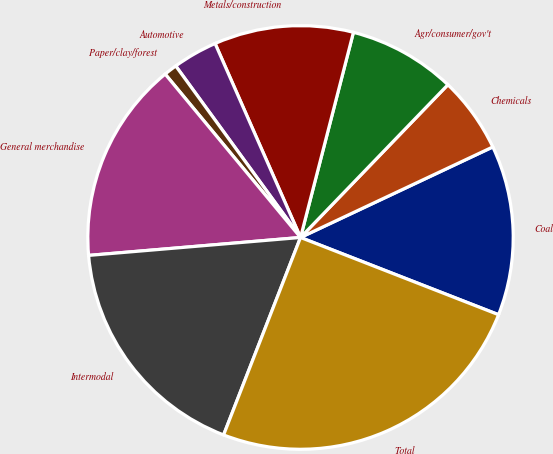<chart> <loc_0><loc_0><loc_500><loc_500><pie_chart><fcel>Coal<fcel>Chemicals<fcel>Agr/consumer/gov't<fcel>Metals/construction<fcel>Automotive<fcel>Paper/clay/forest<fcel>General merchandise<fcel>Intermodal<fcel>Total<nl><fcel>12.97%<fcel>5.79%<fcel>8.18%<fcel>10.58%<fcel>3.4%<fcel>1.0%<fcel>15.37%<fcel>17.76%<fcel>24.95%<nl></chart> 